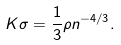Convert formula to latex. <formula><loc_0><loc_0><loc_500><loc_500>K \sigma = \frac { 1 } { 3 } \rho n ^ { - 4 / 3 } .</formula> 